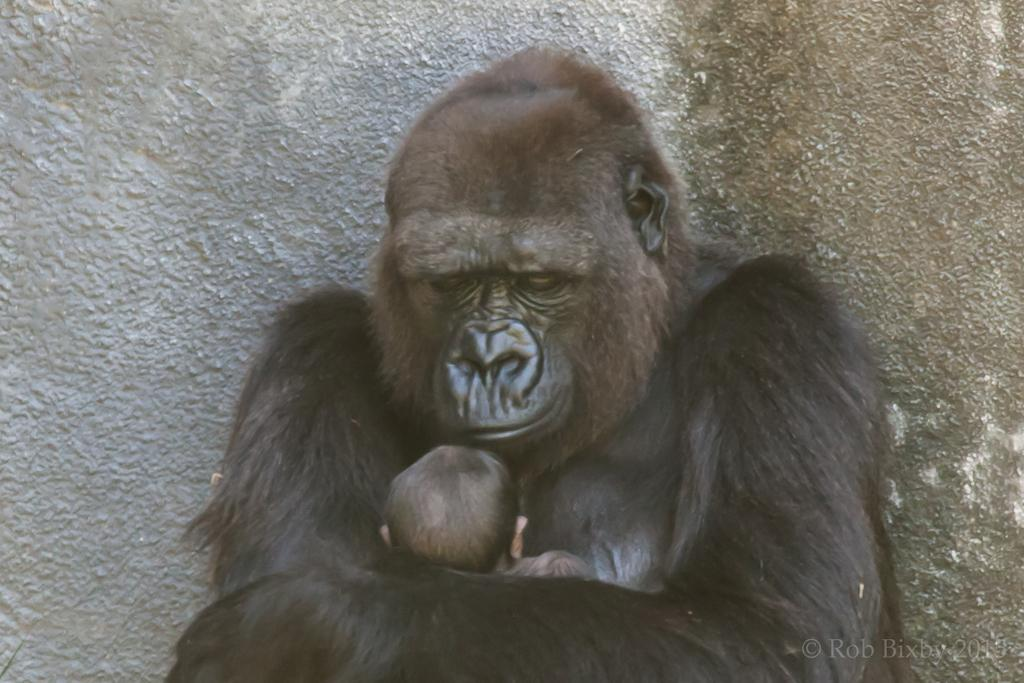What is the gorilla doing in the image? The gorilla is carrying an infant in the image. What can be seen in the background of the image? There is a wall visible in the background of the image. Is there any text or marking on the image? Yes, there is a watermark on the bottom right side of the image. What type of alarm is going off in the image? There is no alarm present in the image; it features a gorilla carrying an infant with a wall in the background and a watermark. 